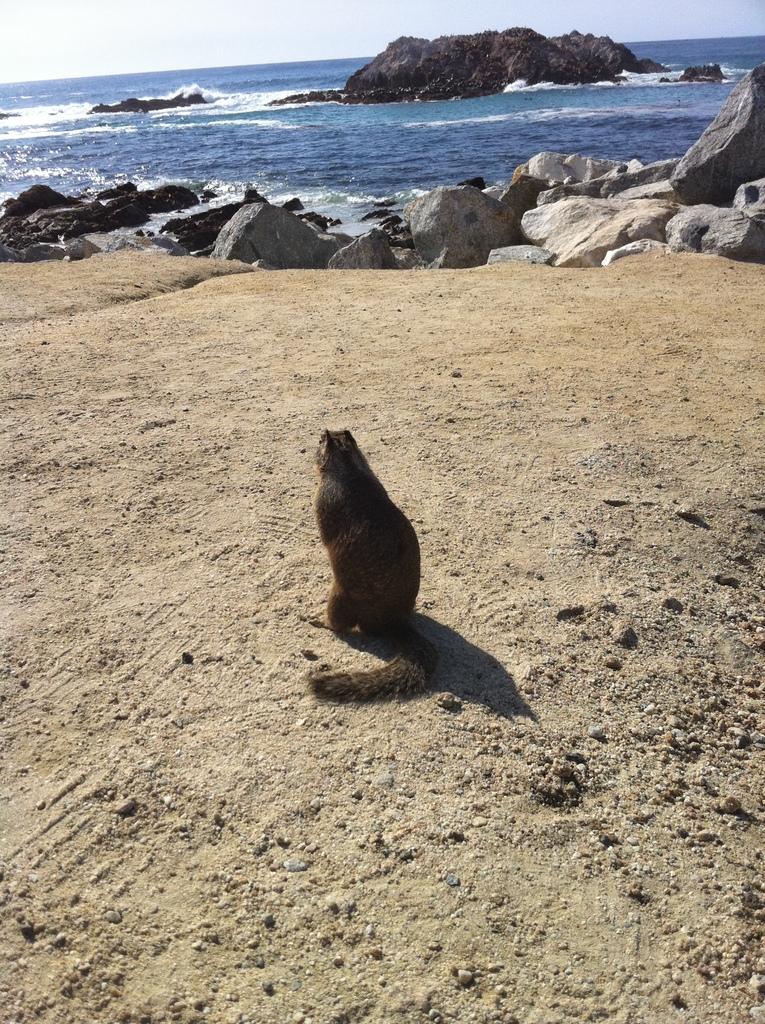Please provide a concise description of this image. In this image we can see an animal on the ground. In the background we can see rocks, water, and sky. 